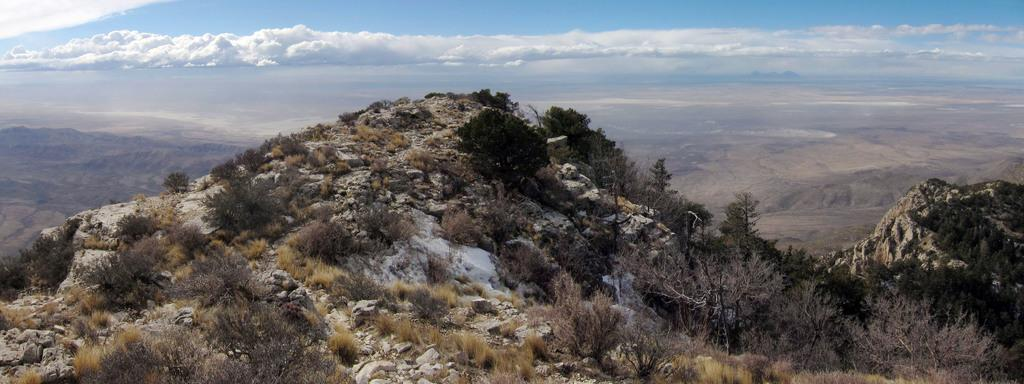What type of terrain is visible in the image? There are hills in the image. What can be seen on the hills? Trees, plants, grass, and stones are present on the hills. What is visible in the background of the image? The sky is visible in the background of the image. What can be observed in the sky? Clouds are present in the sky. What type of acoustics can be heard in the image? There is no sound or acoustics present in the image, as it is a still photograph. What discovery was made on the hills in the image? There is no indication of a discovery being made in the image; it simply shows hills with various elements. 